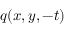<formula> <loc_0><loc_0><loc_500><loc_500>q ( x , y , - t )</formula> 